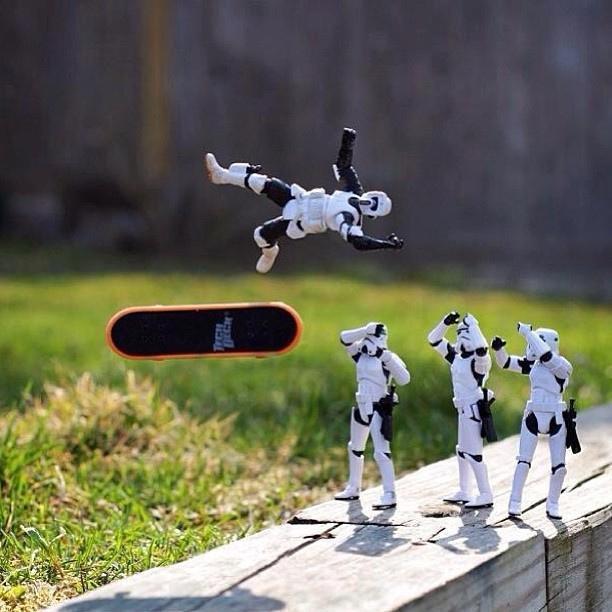How many Star Wars figures are shown?
Give a very brief answer. 4. How many people are there?
Give a very brief answer. 4. 